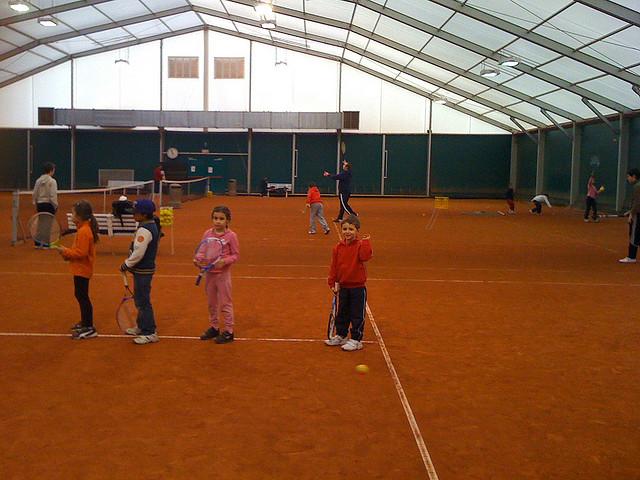Is the whole roof glass?
Short answer required. Yes. How many are playing the game?
Write a very short answer. 4. What sport is this?
Concise answer only. Tennis. Approximately how high is this building?
Write a very short answer. 50 feet. What is the boy in red doing with his hand?
Concise answer only. Waving. 